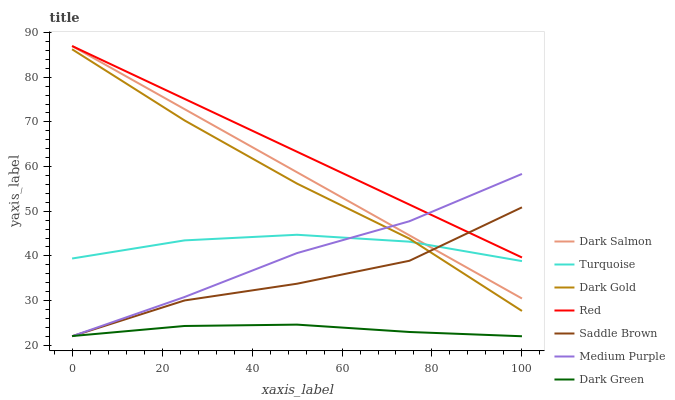Does Dark Green have the minimum area under the curve?
Answer yes or no. Yes. Does Red have the maximum area under the curve?
Answer yes or no. Yes. Does Dark Gold have the minimum area under the curve?
Answer yes or no. No. Does Dark Gold have the maximum area under the curve?
Answer yes or no. No. Is Dark Salmon the smoothest?
Answer yes or no. Yes. Is Saddle Brown the roughest?
Answer yes or no. Yes. Is Dark Gold the smoothest?
Answer yes or no. No. Is Dark Gold the roughest?
Answer yes or no. No. Does Medium Purple have the lowest value?
Answer yes or no. Yes. Does Dark Gold have the lowest value?
Answer yes or no. No. Does Red have the highest value?
Answer yes or no. Yes. Does Dark Gold have the highest value?
Answer yes or no. No. Is Dark Gold less than Dark Salmon?
Answer yes or no. Yes. Is Dark Salmon greater than Dark Green?
Answer yes or no. Yes. Does Saddle Brown intersect Medium Purple?
Answer yes or no. Yes. Is Saddle Brown less than Medium Purple?
Answer yes or no. No. Is Saddle Brown greater than Medium Purple?
Answer yes or no. No. Does Dark Gold intersect Dark Salmon?
Answer yes or no. No. 